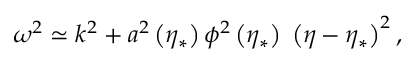<formula> <loc_0><loc_0><loc_500><loc_500>\omega ^ { 2 } \simeq k ^ { 2 } + a ^ { 2 } \left ( \eta _ { * } \right ) \phi ^ { 2 } \left ( \eta _ { * } \right ) \, \left ( \eta - \eta _ { * } \right ) ^ { 2 } ,</formula> 